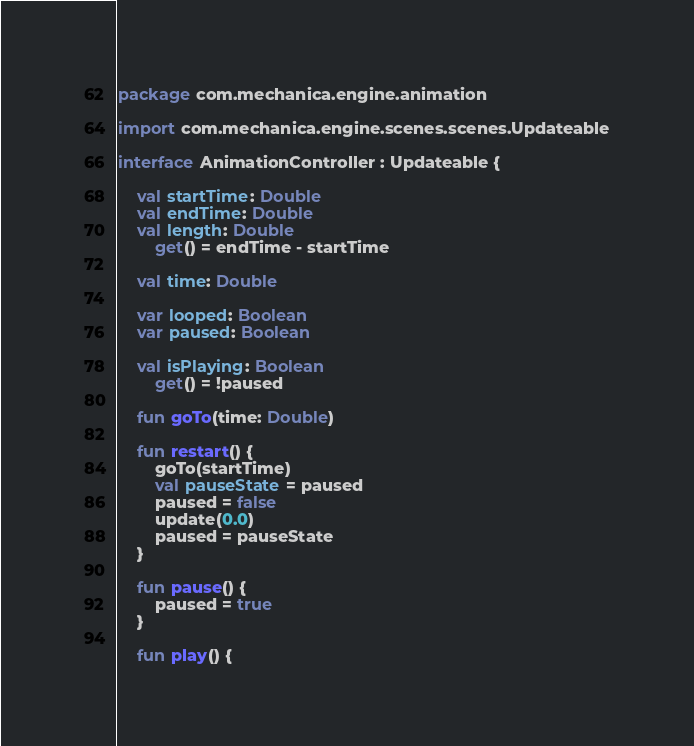<code> <loc_0><loc_0><loc_500><loc_500><_Kotlin_>package com.mechanica.engine.animation

import com.mechanica.engine.scenes.scenes.Updateable

interface AnimationController : Updateable {

    val startTime: Double
    val endTime: Double
    val length: Double
        get() = endTime - startTime

    val time: Double

    var looped: Boolean
    var paused: Boolean

    val isPlaying: Boolean
        get() = !paused

    fun goTo(time: Double)

    fun restart() {
        goTo(startTime)
        val pauseState = paused
        paused = false
        update(0.0)
        paused = pauseState
    }

    fun pause() {
        paused = true
    }

    fun play() {</code> 